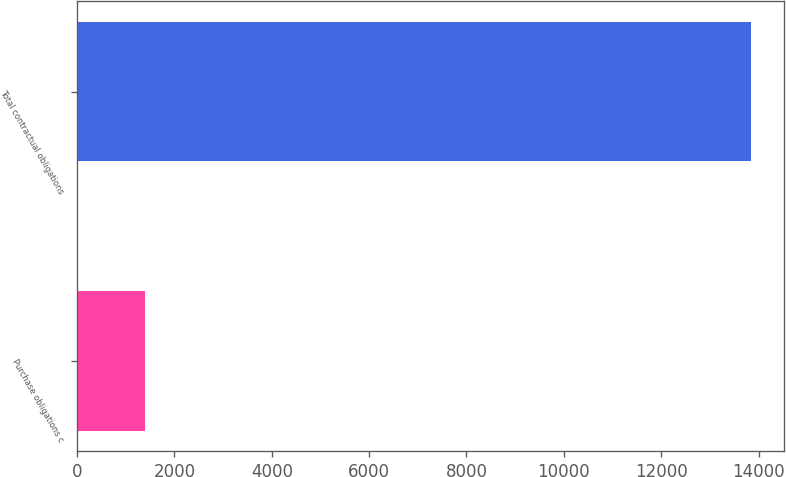Convert chart. <chart><loc_0><loc_0><loc_500><loc_500><bar_chart><fcel>Purchase obligations c<fcel>Total contractual obligations<nl><fcel>1387<fcel>13836<nl></chart> 